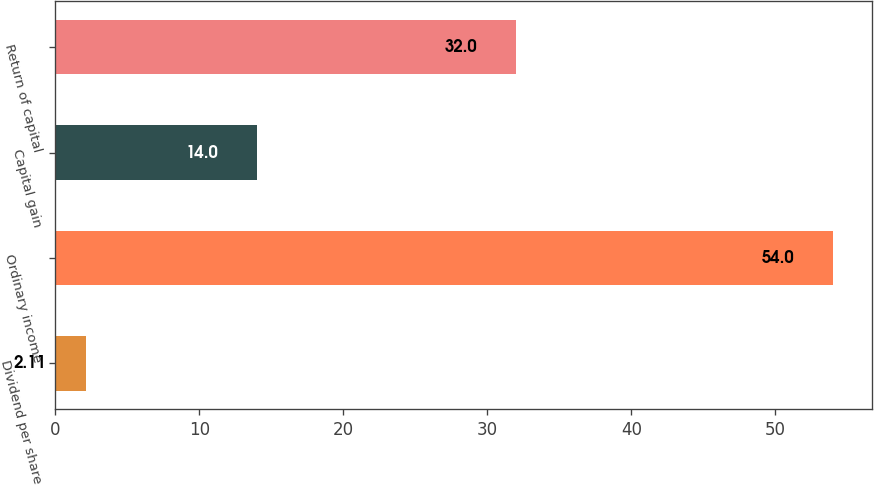Convert chart. <chart><loc_0><loc_0><loc_500><loc_500><bar_chart><fcel>Dividend per share<fcel>Ordinary income<fcel>Capital gain<fcel>Return of capital<nl><fcel>2.11<fcel>54<fcel>14<fcel>32<nl></chart> 